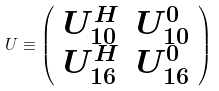<formula> <loc_0><loc_0><loc_500><loc_500>U \equiv \left ( \begin{array} { c c } U _ { 1 0 } ^ { H } & U _ { 1 0 } ^ { 0 } \\ U _ { 1 6 } ^ { H } & U _ { 1 6 } ^ { 0 } \end{array} \right )</formula> 